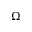<formula> <loc_0><loc_0><loc_500><loc_500>\Omega</formula> 